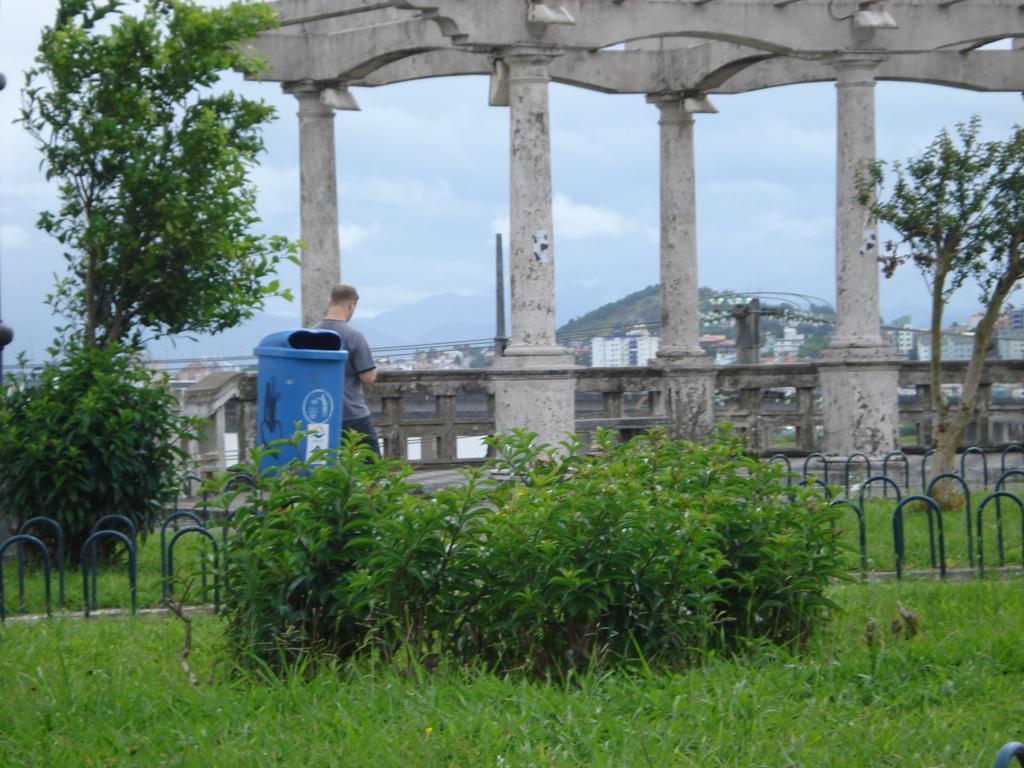Describe this image in one or two sentences. In this image I can see some grass on the ground, few plants which are green in color, the railing, the blue color dustbin, few trees and a person standing on the ground. In the background I can see few pillars, few buildings, few trees, a mountain and the sky. 